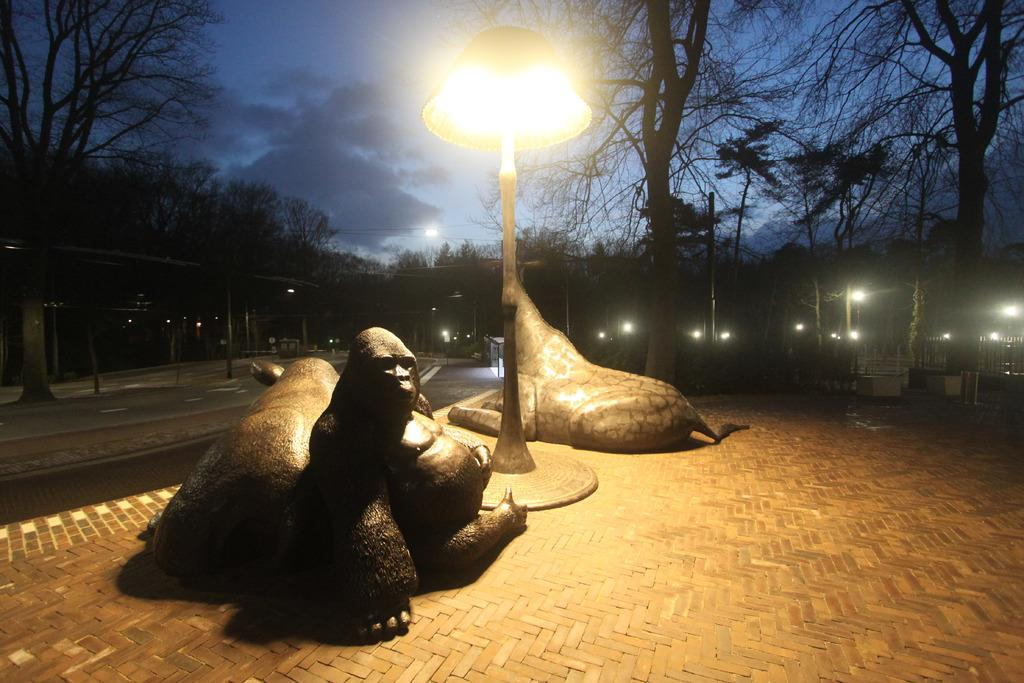How many statues are present in the image? There are three statues in the image. What is attached to the pole in the image? There is a light attached to a pole in the image. What can be seen in the background of the image? There are trees and lights in the background of the image. What is the caption for the image? There is no caption provided with the image, so it cannot be determined. 